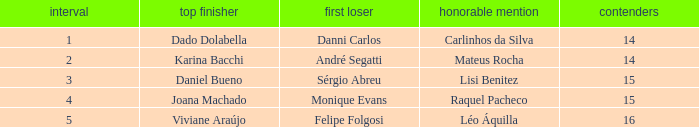Would you mind parsing the complete table? {'header': ['interval', 'top finisher', 'first loser', 'honorable mention', 'contenders'], 'rows': [['1', 'Dado Dolabella', 'Danni Carlos', 'Carlinhos da Silva', '14'], ['2', 'Karina Bacchi', 'André Segatti', 'Mateus Rocha', '14'], ['3', 'Daniel Bueno', 'Sérgio Abreu', 'Lisi Benitez', '15'], ['4', 'Joana Machado', 'Monique Evans', 'Raquel Pacheco', '15'], ['5', 'Viviane Araújo', 'Felipe Folgosi', 'Léo Áquilla', '16']]} Who was the winner when Mateus Rocha finished in 3rd place?  Karina Bacchi. 